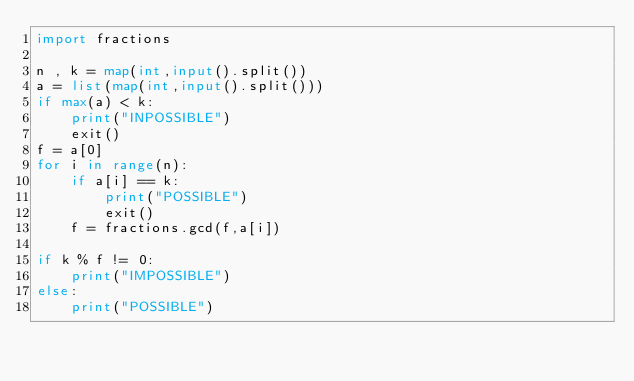<code> <loc_0><loc_0><loc_500><loc_500><_Python_>import fractions

n , k = map(int,input().split())
a = list(map(int,input().split()))
if max(a) < k:
    print("INPOSSIBLE")
    exit()
f = a[0]
for i in range(n):
    if a[i] == k:
        print("POSSIBLE")
        exit()
    f = fractions.gcd(f,a[i])
    
if k % f != 0:
    print("IMPOSSIBLE")
else:
    print("POSSIBLE")</code> 